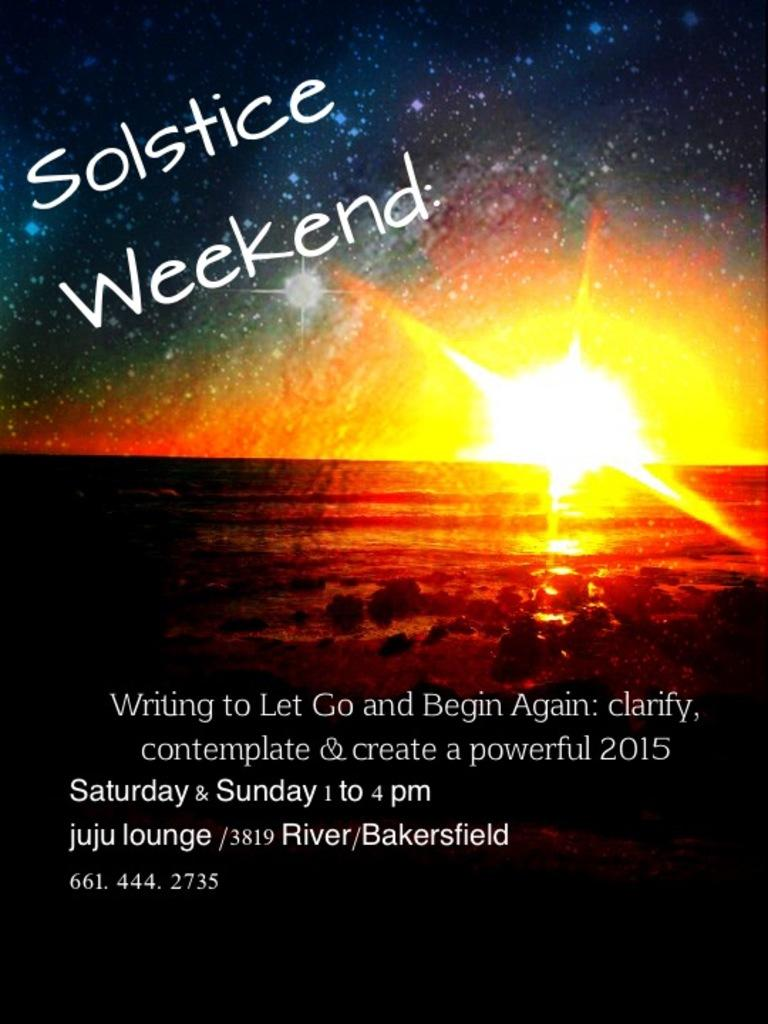<image>
Summarize the visual content of the image. a Solstice Weekend advertisement with a sunset on it 